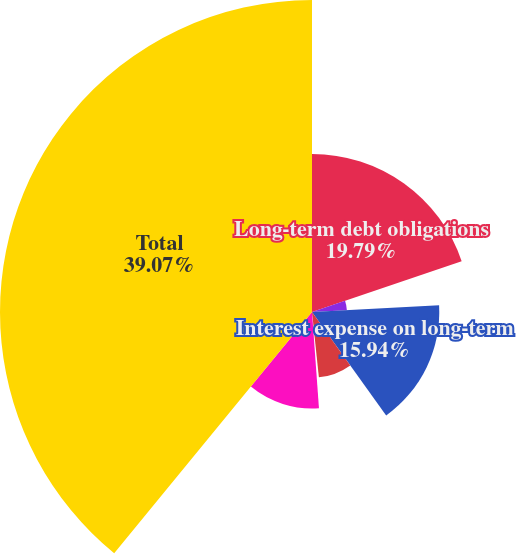<chart> <loc_0><loc_0><loc_500><loc_500><pie_chart><fcel>Long-term debt obligations<fcel>Capital lease obligations<fcel>Interest expense on long-term<fcel>Satellite-related obligations<fcel>Operating lease obligations<fcel>Purchase obligations<fcel>Total<nl><fcel>19.79%<fcel>4.37%<fcel>15.94%<fcel>8.23%<fcel>0.52%<fcel>12.08%<fcel>39.07%<nl></chart> 